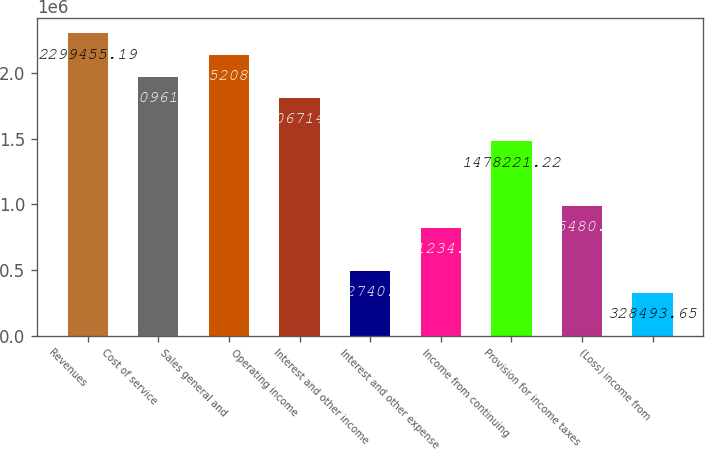<chart> <loc_0><loc_0><loc_500><loc_500><bar_chart><fcel>Revenues<fcel>Cost of service<fcel>Sales general and<fcel>Operating income<fcel>Interest and other income<fcel>Interest and other expense<fcel>Income from continuing<fcel>Provision for income taxes<fcel>(Loss) income from<nl><fcel>2.29946e+06<fcel>1.97096e+06<fcel>2.13521e+06<fcel>1.80671e+06<fcel>492740<fcel>821234<fcel>1.47822e+06<fcel>985481<fcel>328494<nl></chart> 